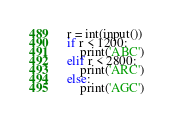<code> <loc_0><loc_0><loc_500><loc_500><_Python_>r = int(input())
if r < 1200:
    print('ABC')
elif r < 2800:
    print('ARC')
else:
    print('AGC')</code> 